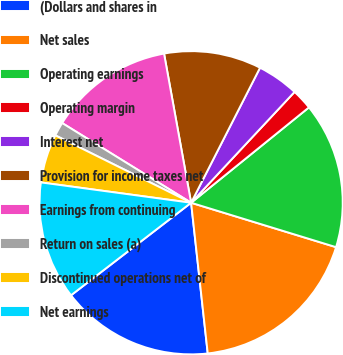Convert chart to OTSL. <chart><loc_0><loc_0><loc_500><loc_500><pie_chart><fcel>(Dollars and shares in<fcel>Net sales<fcel>Operating earnings<fcel>Operating margin<fcel>Interest net<fcel>Provision for income taxes net<fcel>Earnings from continuing<fcel>Return on sales (a)<fcel>Discontinued operations net of<fcel>Net earnings<nl><fcel>16.3%<fcel>18.52%<fcel>15.56%<fcel>2.22%<fcel>4.44%<fcel>10.37%<fcel>13.33%<fcel>1.48%<fcel>5.19%<fcel>12.59%<nl></chart> 